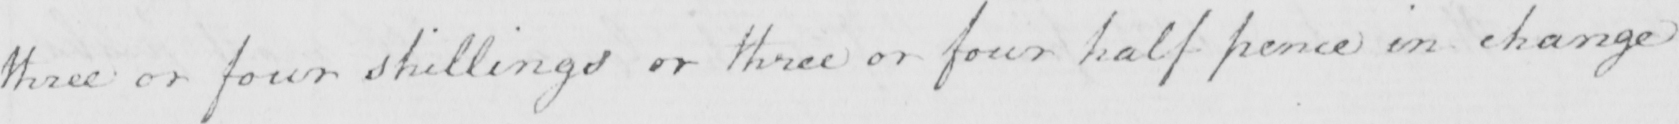Transcribe the text shown in this historical manuscript line. three or four shillings or three or four half pence in change 